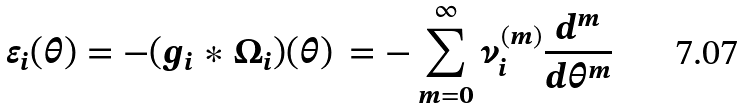Convert formula to latex. <formula><loc_0><loc_0><loc_500><loc_500>\varepsilon _ { i } ( \theta ) = - ( g _ { i } \ast \Omega _ { i } ) ( \theta ) \, = - \sum _ { m = 0 } ^ { \infty } \nu _ { i } ^ { ( m ) } \frac { d ^ { m } } { d \theta ^ { m } }</formula> 